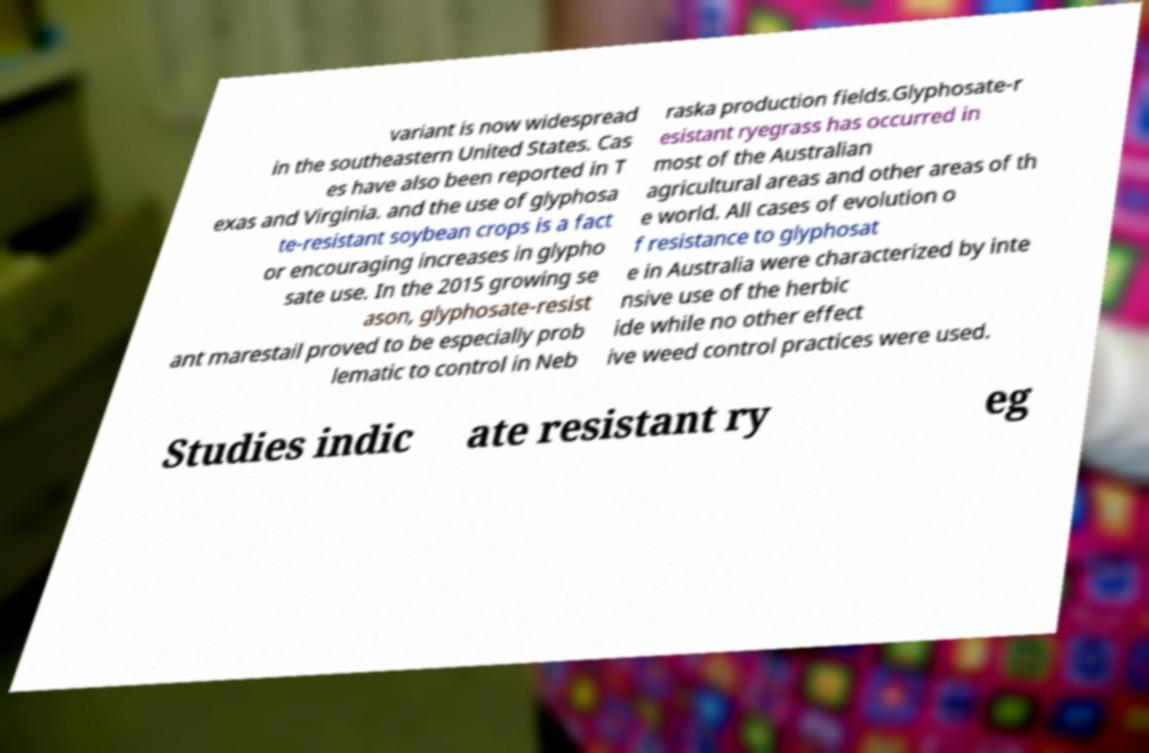For documentation purposes, I need the text within this image transcribed. Could you provide that? variant is now widespread in the southeastern United States. Cas es have also been reported in T exas and Virginia. and the use of glyphosa te-resistant soybean crops is a fact or encouraging increases in glypho sate use. In the 2015 growing se ason, glyphosate-resist ant marestail proved to be especially prob lematic to control in Neb raska production fields.Glyphosate-r esistant ryegrass has occurred in most of the Australian agricultural areas and other areas of th e world. All cases of evolution o f resistance to glyphosat e in Australia were characterized by inte nsive use of the herbic ide while no other effect ive weed control practices were used. Studies indic ate resistant ry eg 